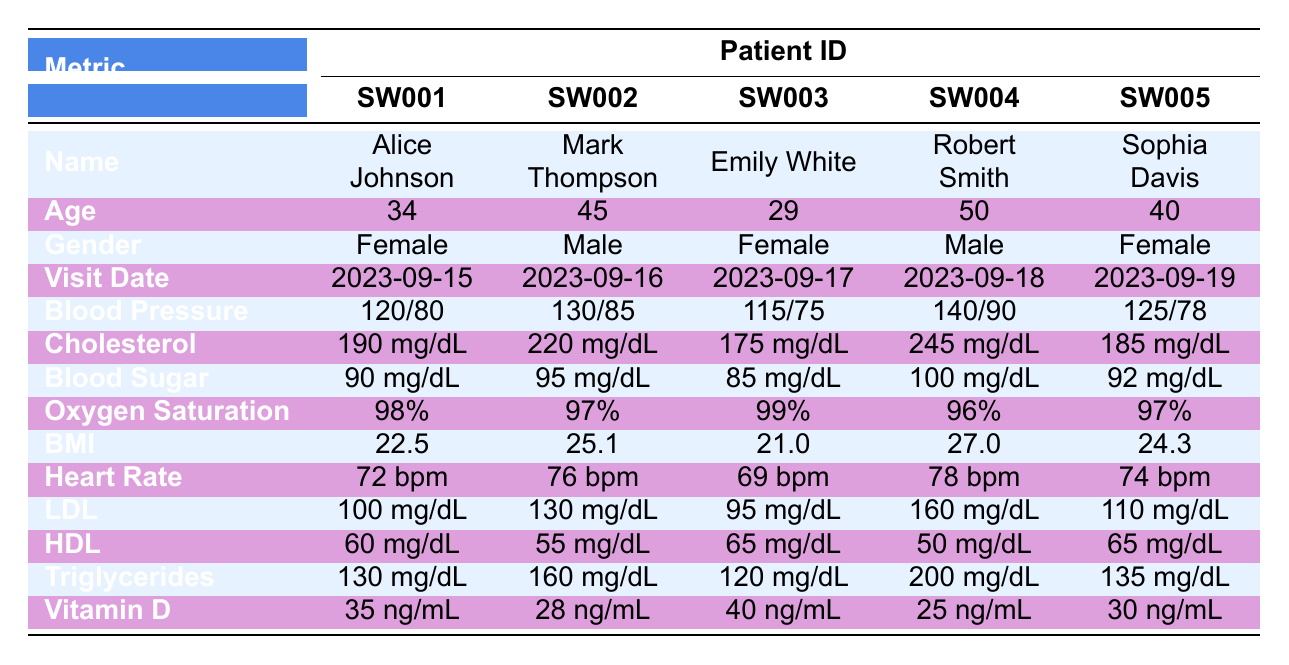What is the blood pressure of Mark Thompson? In the table, we look for Mark Thompson in the "Patient ID" column and find his corresponding blood pressure listed under the "Blood Pressure" row. His blood pressure is recorded as 130/85.
Answer: 130/85 What is the age of the youngest patient? We can find the ages of all patients in the "Age" row: Alice Johnson (34), Mark Thompson (45), Emily White (29), Robert Smith (50), and Sophia Davis (40). The youngest age is 29, belonging to Emily White.
Answer: 29 Is Robert Smith's cholesterol above 240 mg/dL? By checking Robert Smith's cholesterol value in the "Cholesterol" row, we see that his cholesterol level is 245 mg/dL. Since 245 mg/dL is greater than 240 mg/dL, the answer is yes.
Answer: Yes What is the average body mass index (BMI) of all patients? To calculate the average BMI, we need to add all the BMI values: 22.5 + 25.1 + 21.0 + 27.0 + 24.3 = 120.9. Then, we divide this sum by the number of patients (5): 120.9 / 5 = 24.18.
Answer: 24.18 Which patient has the highest LDL cholesterol level? The LDL levels are listed for each patient: Alice Johnson (100 mg/dL), Mark Thompson (130 mg/dL), Emily White (95 mg/dL), Robert Smith (160 mg/dL), and Sophia Davis (110 mg/dL). The highest value is 160 mg/dL, which belongs to Robert Smith.
Answer: Robert Smith What is the vitamin D level of Emily White? Looking at the "Vitamin D" row, we see that Emily White's vitamin D level is listed as 40 ng/mL.
Answer: 40 ng/mL Does any patient have a heart rate of less than 70 bpm? Checking the "Heart Rate" row, we find the rates: Alice Johnson (72 bpm), Mark Thompson (76 bpm), Emily White (69 bpm), Robert Smith (78 bpm), and Sophia Davis (74 bpm). Emily White has a heart rate of 69 bpm, which is less than 70 bpm.
Answer: Yes What is the difference in cholesterol levels between the oldest and youngest patients? The cholesterol levels of the oldest (Robert Smith, 245 mg/dL) and the youngest patient (Emily White, 175 mg/dL) must be subtracted: 245 - 175 = 70 mg/dL.
Answer: 70 mg/dL 